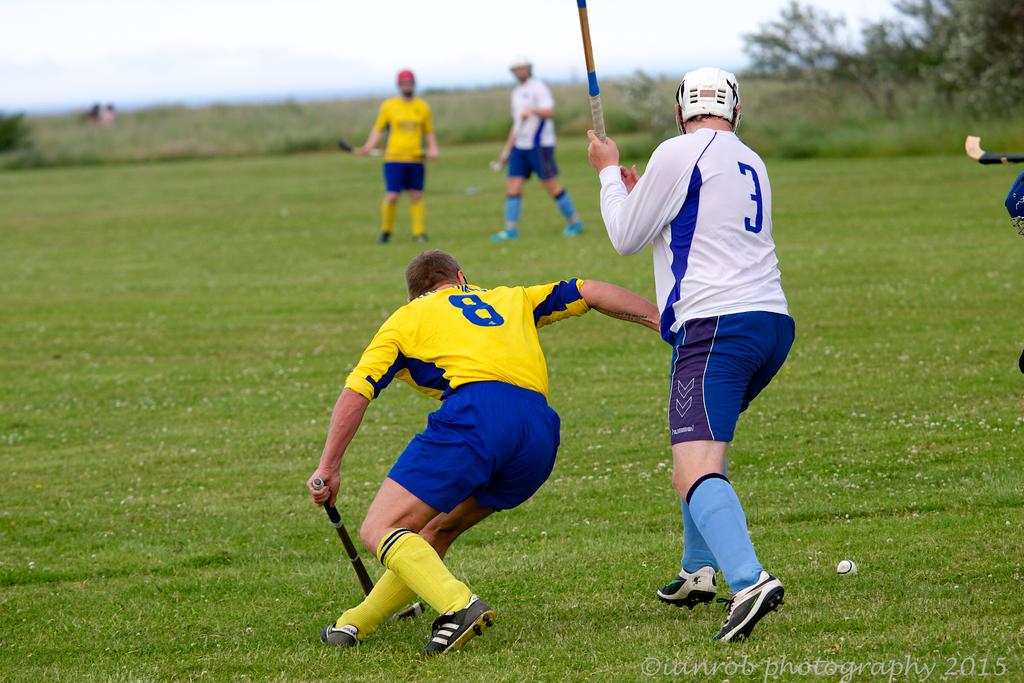What number is one of these lacrosse players?
Your answer should be compact. 3. What number is the man in white?
Ensure brevity in your answer.  3. 